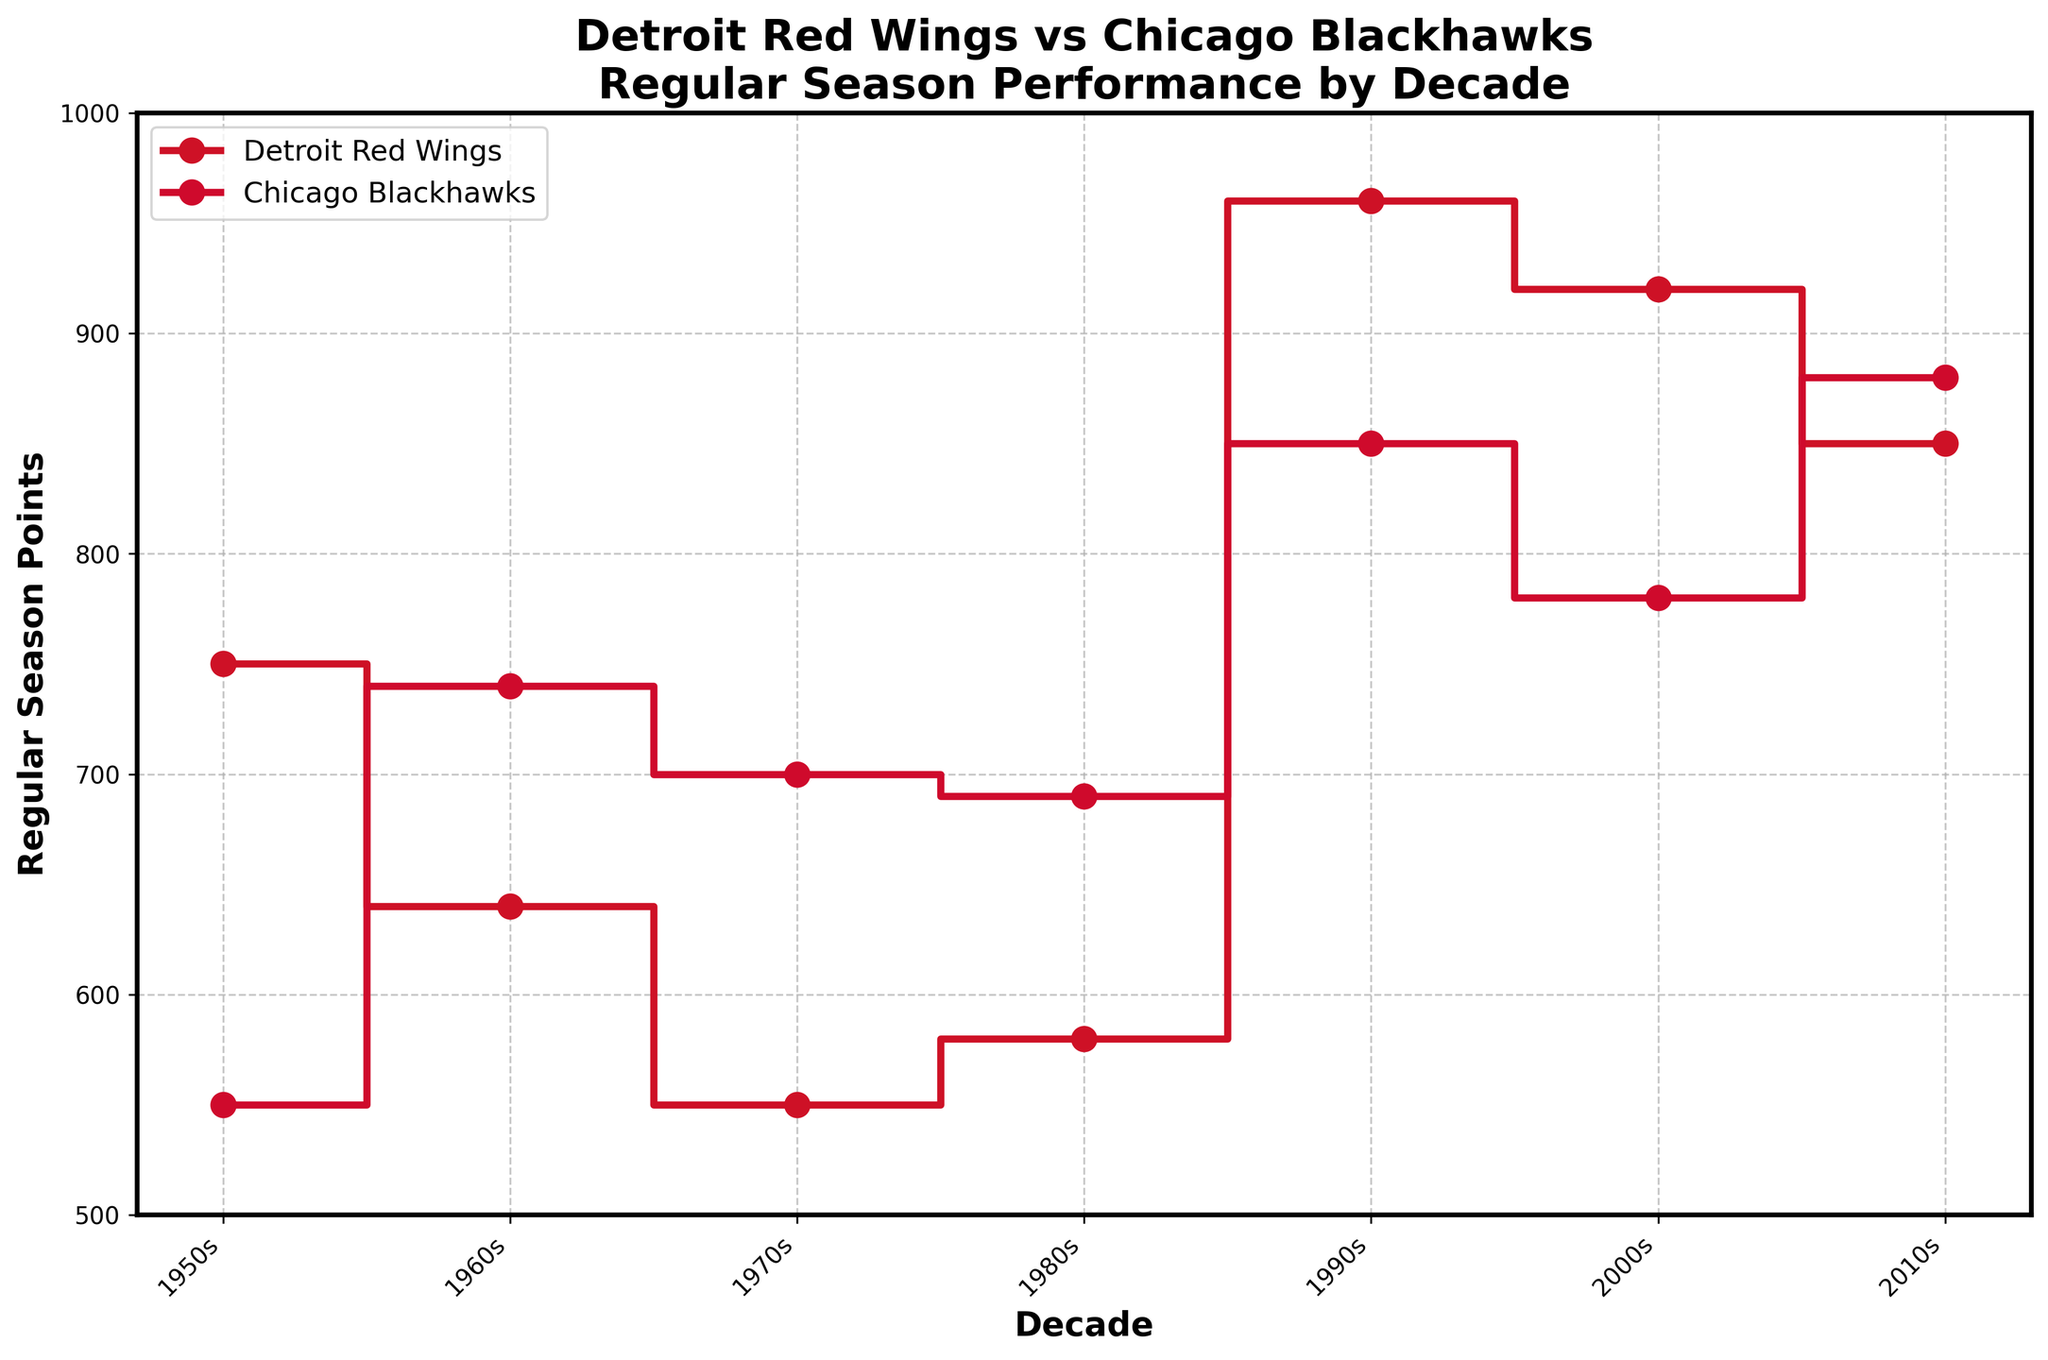What's the title of the figure? The title of the figure is displayed at the top of the plot.
Answer: Detroit Red Wings vs Chicago Blackhawks Regular Season Performance by Decade What are the teams compared in the figure? The teams are labeled in the legend at the upper left of the figure.
Answer: Detroit Red Wings and Chicago Blackhawks Which team had higher regular season points in the 1950s? By looking at the plot for the 1950s, observe which step line is higher. The Detroit Red Wings' line is significantly higher.
Answer: Detroit Red Wings In which decade did the Chicago Blackhawks have the highest regular season points? Compare the heights of the step lines for each decade for the Chicago Blackhawks and identify the highest point. The highest occurs in the 2010s.
Answer: 2010s How many regular season points did the Detroit Red Wings score in the 1990s? Refer to the marked point on the Detroit Red Wings' step line in the 1990s. The value indicated is 960 points.
Answer: 960 What was the difference in regular season points between the teams in the 2000s? Compare the points on the step lines for both teams in the 2000s. Detroit Red Wings: 920 points, Chicago Blackhawks: 780 points. The difference is 920 - 780.
Answer: 140 In which decades did the Detroit Red Wings have higher regular season points than the Chicago Blackhawks? Compare the step lines for both teams across all decades and identify where the Detroit Red Wings' line is higher.
Answer: 1950s, 1990s, 2000s How many regular season points did each team attain in total over all the decades? Sum the regular season points for each decade from the plot for both teams. Detroit Red Wings: (750+640+550+580+960+920+850), Chicago Blackhawks: (550+740+700+690+850+780+880).
Answer: Detroit Red Wings: 5250, Chicago Blackhawks: 5190 In which decade do both teams have the closest regular season points? Check the plot for the smallest difference between the step lines in any decade. The closest points occur in the 2010s with a difference of 30 points (880 - 850).
Answer: 2010s Which team showed the most improvement from one decade to the next, and in which period? Compare changes from one decade to the next for each team. Chicago Blackhawks show the most improvement from the 2000s to the 2010s (880 - 780) = 100 points.
Answer: Chicago Blackhawks from the 2000s to the 2010s 